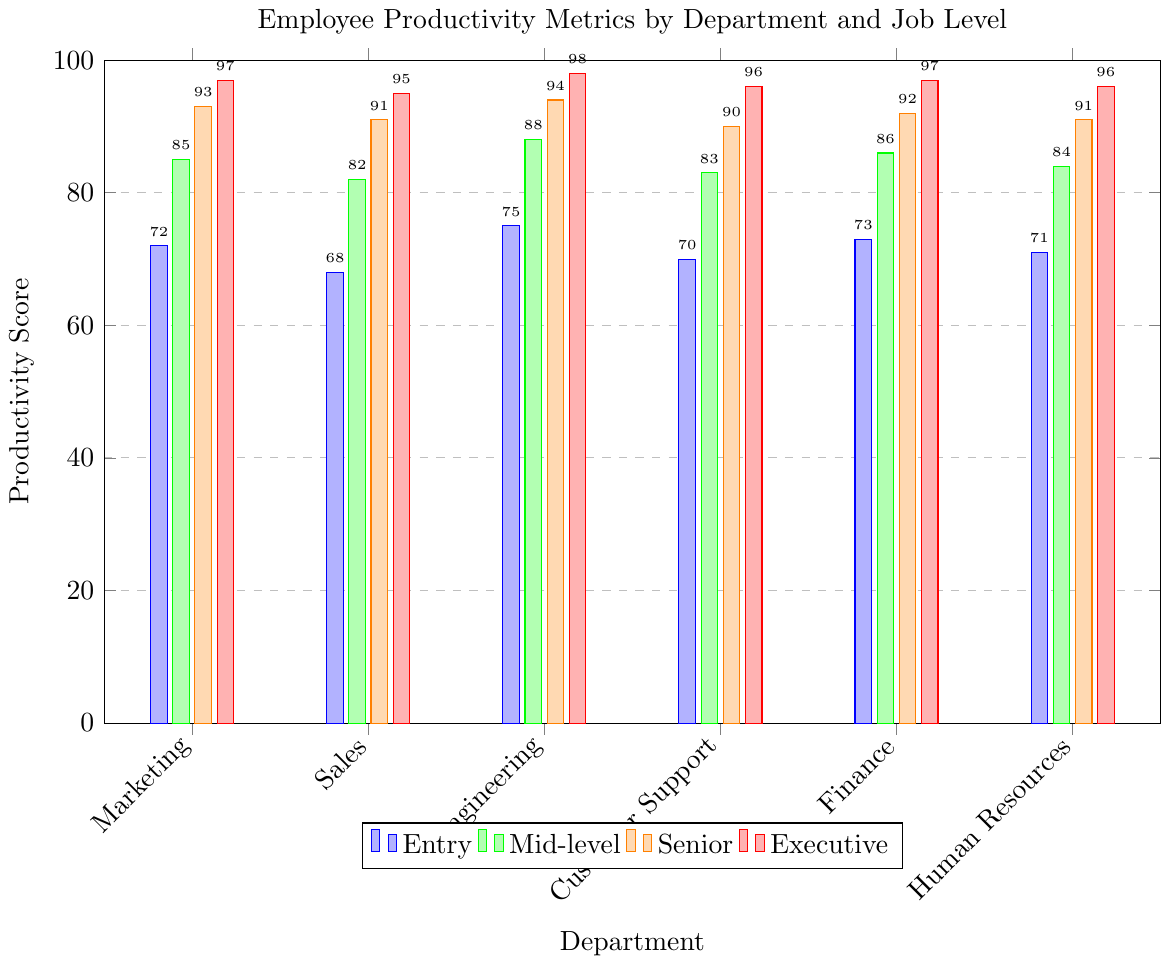Which department has the highest productivity score at the Executive job level? Look at the bars representing the Executive job level, which are colored red. Compare the heights of the red bars for each department. Engineering has the tallest red bar, indicating the highest productivity score.
Answer: Engineering How much higher is the productivity score for Senior level employees compared to Entry level employees in the Sales department? Identify the bars for the Sales department for both the Entry (blue) and Senior (orange) levels. Subtract the height of the blue bar from the height of the orange bar. The Entry level score is 68, and the Senior level score is 91. The difference is 91 - 68 = 23.
Answer: 23 What is the average productivity score for Mid-level employees across all departments? Find the green bars representing the Mid-level employees in each department. Sum their heights and then divide by the number of departments. The Mid-level scores are 85, 82, 88, 83, 86, and 84. The sum is 85 + 82 + 88 + 83 + 86 + 84 = 508. There are 6 departments, so the average is 508 / 6 ≈ 84.67.
Answer: 84.67 Is the entry-level productivity score in Marketing higher or lower than in Finance? Compare the heights of the blue bars for Marketing and Finance. The Marketing score is 72, and the Finance score is 73. Since 72 is less than 73, the entry-level productivity score in Marketing is lower.
Answer: Lower Which job level has the least variation in productivity scores across all departments? Assess the height differences in the bars for each job level across all departments. Entry (blue), Mid-level (green), Senior (orange), and Executive (red) levels need to be compared. The Executive level shows smaller differences in height compared to the other levels, indicating the least variation.
Answer: Executive What is the total productivity score for Human Resources across all job levels? Add the heights of the bars for Human Resources for each job level. The scores are 71 (Entry), 84 (Mid-level), 91 (Senior), and 96 (Executive). The total is 71 + 84 + 91 + 96 = 342.
Answer: 342 How does the productivity score for Senior employees in Customer Support compare to Senior employees in Marketing? Compare the heights of the orange bars for Senior level in Customer Support and Marketing. The Customer Support score is 90, and the Marketing score is 93. Therefore, the score for Senior employees in Customer Support is lower than in Marketing.
Answer: Lower 